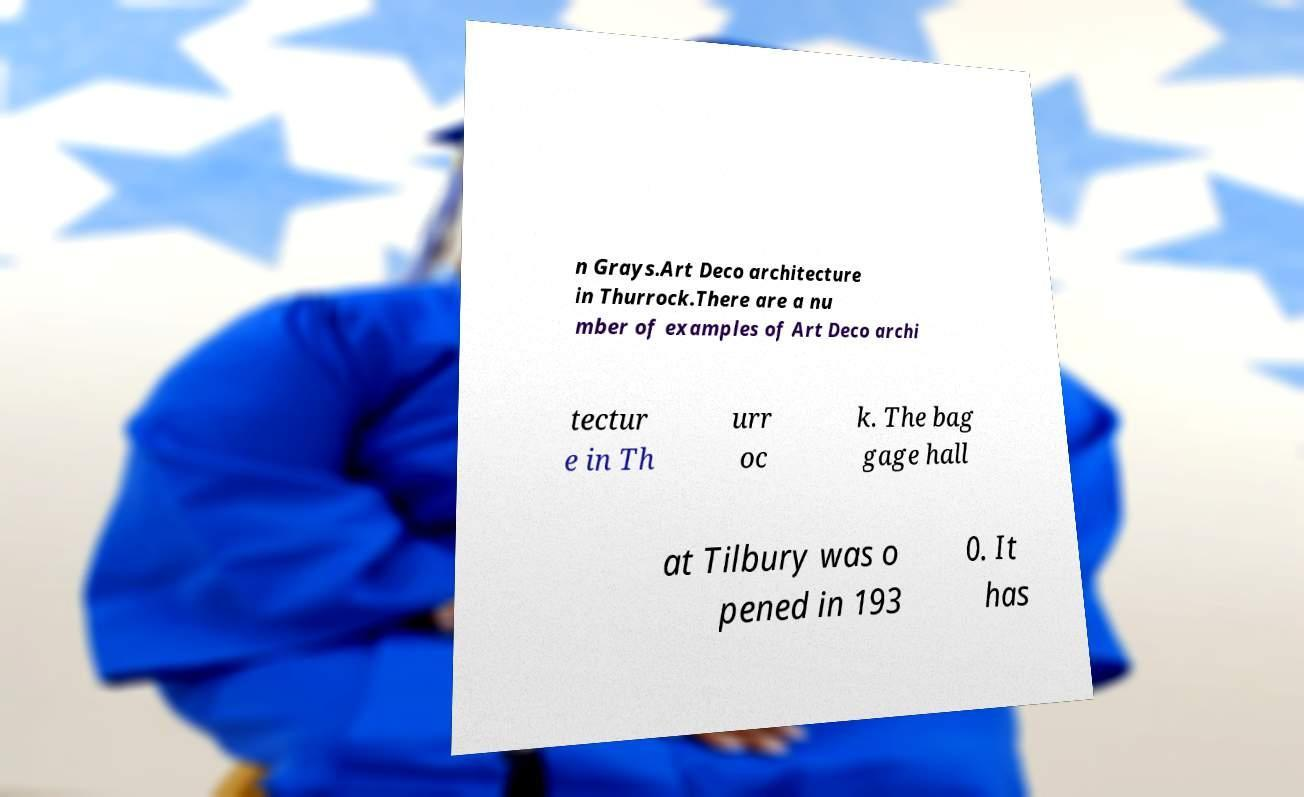I need the written content from this picture converted into text. Can you do that? n Grays.Art Deco architecture in Thurrock.There are a nu mber of examples of Art Deco archi tectur e in Th urr oc k. The bag gage hall at Tilbury was o pened in 193 0. It has 